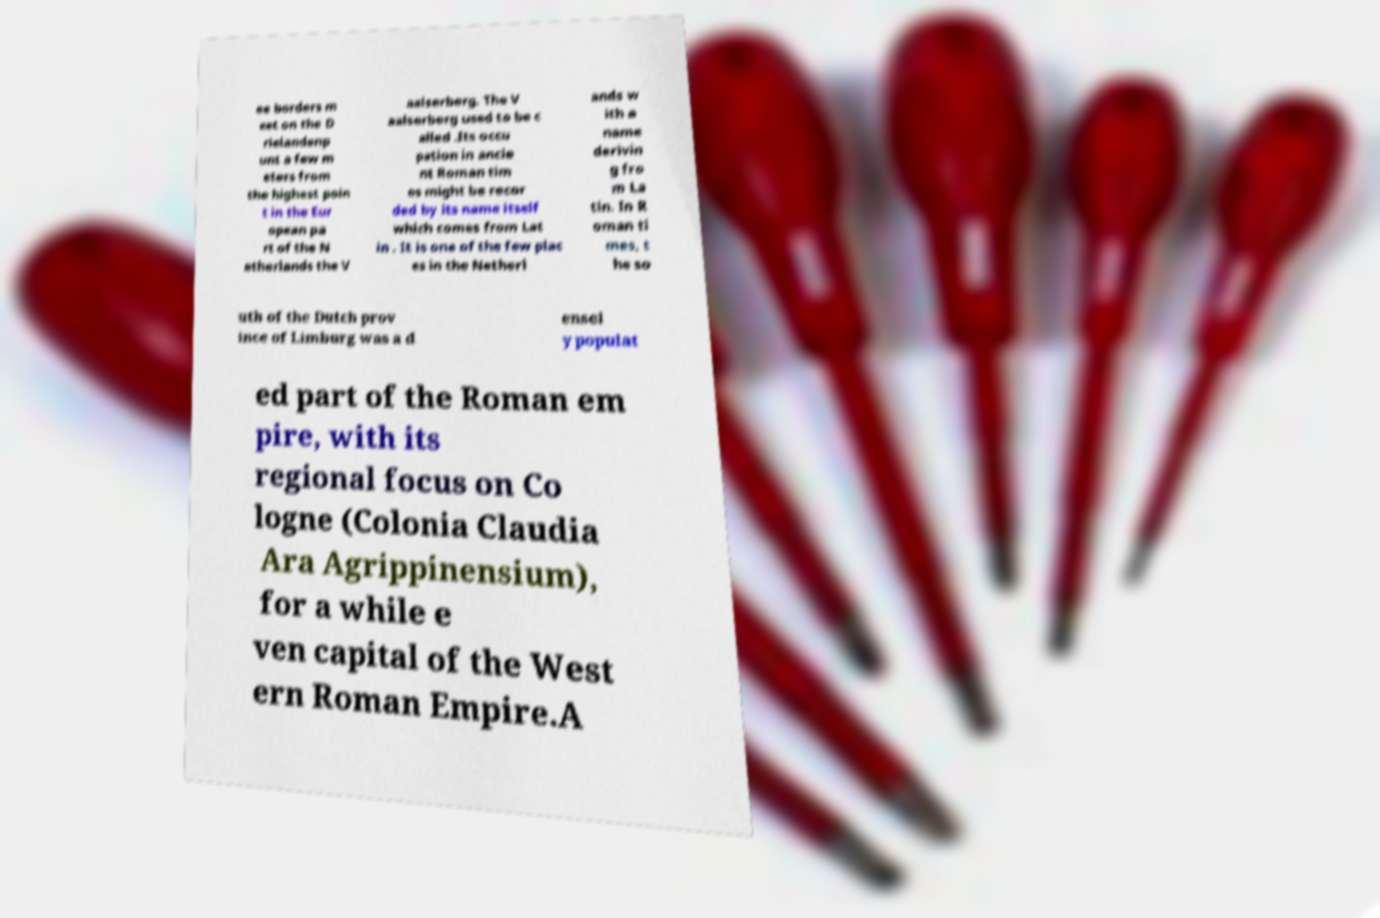Could you assist in decoding the text presented in this image and type it out clearly? ee borders m eet on the D rielandenp unt a few m eters from the highest poin t in the Eur opean pa rt of the N etherlands the V aalserberg. The V aalserberg used to be c alled .Its occu pation in ancie nt Roman tim es might be recor ded by its name itself which comes from Lat in . It is one of the few plac es in the Netherl ands w ith a name derivin g fro m La tin. In R oman ti mes, t he so uth of the Dutch prov ince of Limburg was a d ensel y populat ed part of the Roman em pire, with its regional focus on Co logne (Colonia Claudia Ara Agrippinensium), for a while e ven capital of the West ern Roman Empire.A 